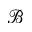<formula> <loc_0><loc_0><loc_500><loc_500>\ m a t h s c r { B }</formula> 